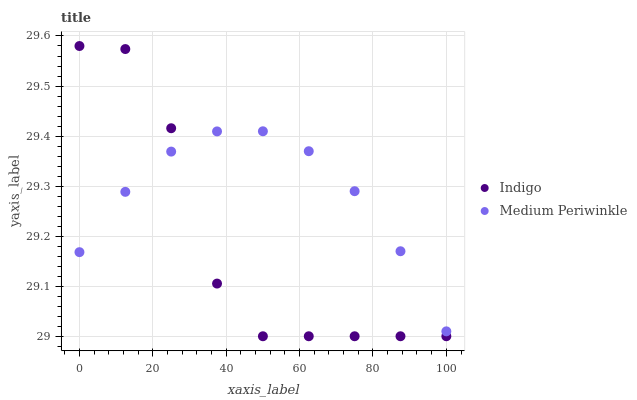Does Indigo have the minimum area under the curve?
Answer yes or no. Yes. Does Medium Periwinkle have the maximum area under the curve?
Answer yes or no. Yes. Does Indigo have the maximum area under the curve?
Answer yes or no. No. Is Medium Periwinkle the smoothest?
Answer yes or no. Yes. Is Indigo the roughest?
Answer yes or no. Yes. Is Indigo the smoothest?
Answer yes or no. No. Does Indigo have the lowest value?
Answer yes or no. Yes. Does Indigo have the highest value?
Answer yes or no. Yes. Does Indigo intersect Medium Periwinkle?
Answer yes or no. Yes. Is Indigo less than Medium Periwinkle?
Answer yes or no. No. Is Indigo greater than Medium Periwinkle?
Answer yes or no. No. 